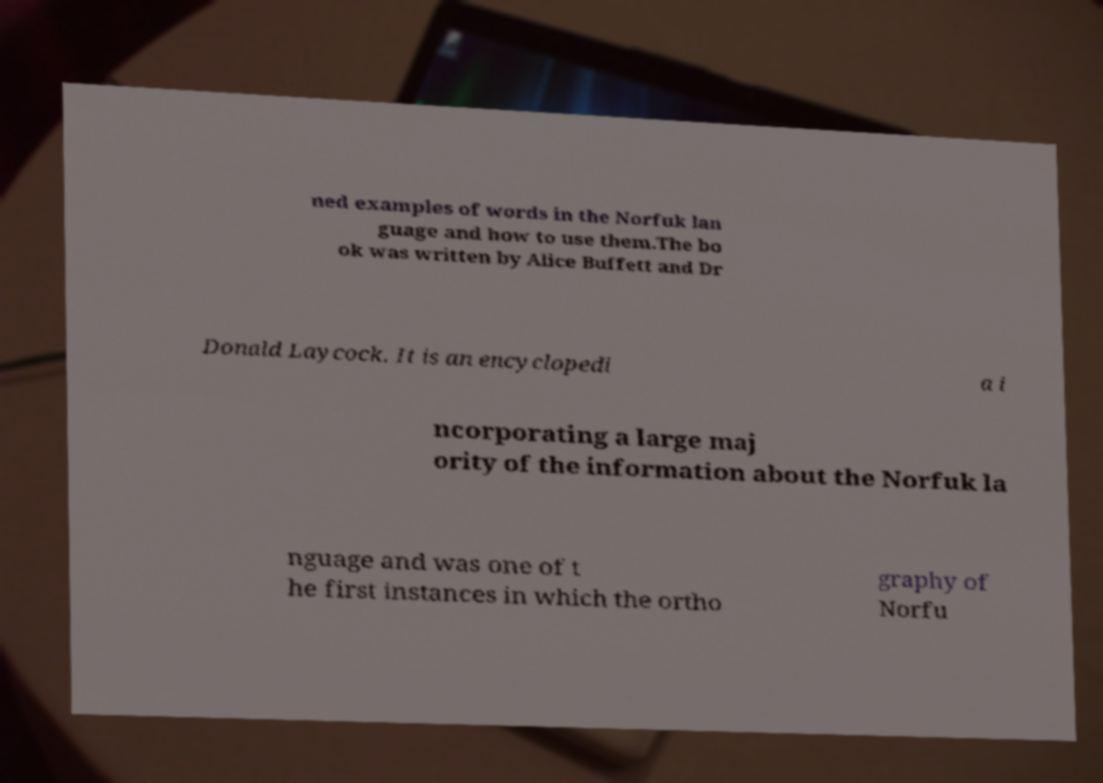For documentation purposes, I need the text within this image transcribed. Could you provide that? ned examples of words in the Norfuk lan guage and how to use them.The bo ok was written by Alice Buffett and Dr Donald Laycock. It is an encyclopedi a i ncorporating a large maj ority of the information about the Norfuk la nguage and was one of t he first instances in which the ortho graphy of Norfu 